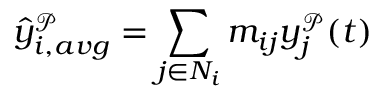<formula> <loc_0><loc_0><loc_500><loc_500>\hat { y } _ { i , a v g } ^ { \mathcal { P } } = \sum _ { j \in N _ { i } } m _ { i j } y _ { j } ^ { \mathcal { P } } ( t )</formula> 